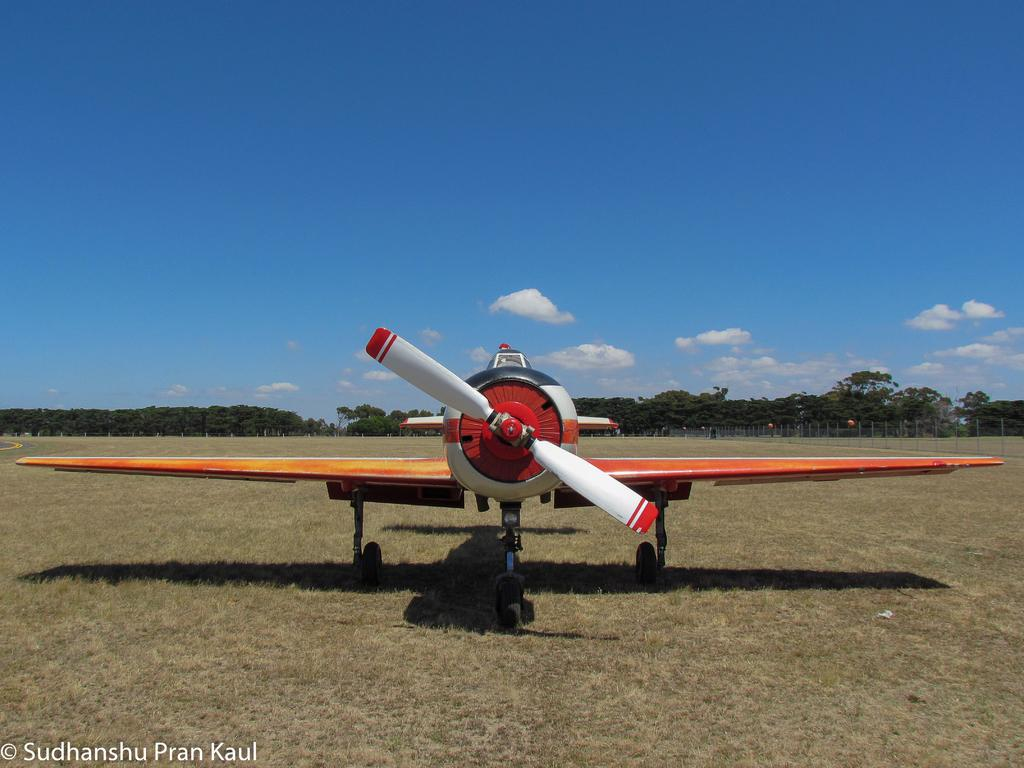What is the main subject in the foreground of the image? There is an airplane in the foreground of the image. What is the current state of the airplane? The airplane is on the ground. What can be seen in the background of the image? There are trees and the sky visible in the background of the image. What is the condition of the sky in the image? The sky has clouds in it. Where is the pin located in the image? There is no pin present in the image. What type of rod can be seen supporting the airplane in the image? There is no rod supporting the airplane in the image; it is on the ground. 